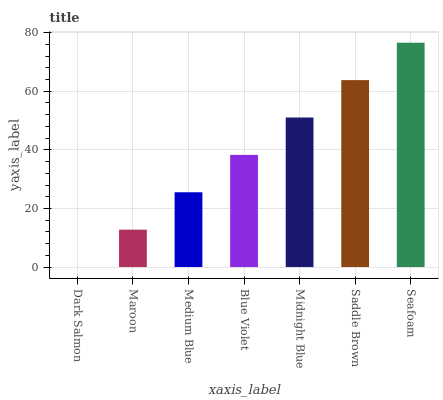Is Dark Salmon the minimum?
Answer yes or no. Yes. Is Seafoam the maximum?
Answer yes or no. Yes. Is Maroon the minimum?
Answer yes or no. No. Is Maroon the maximum?
Answer yes or no. No. Is Maroon greater than Dark Salmon?
Answer yes or no. Yes. Is Dark Salmon less than Maroon?
Answer yes or no. Yes. Is Dark Salmon greater than Maroon?
Answer yes or no. No. Is Maroon less than Dark Salmon?
Answer yes or no. No. Is Blue Violet the high median?
Answer yes or no. Yes. Is Blue Violet the low median?
Answer yes or no. Yes. Is Maroon the high median?
Answer yes or no. No. Is Midnight Blue the low median?
Answer yes or no. No. 